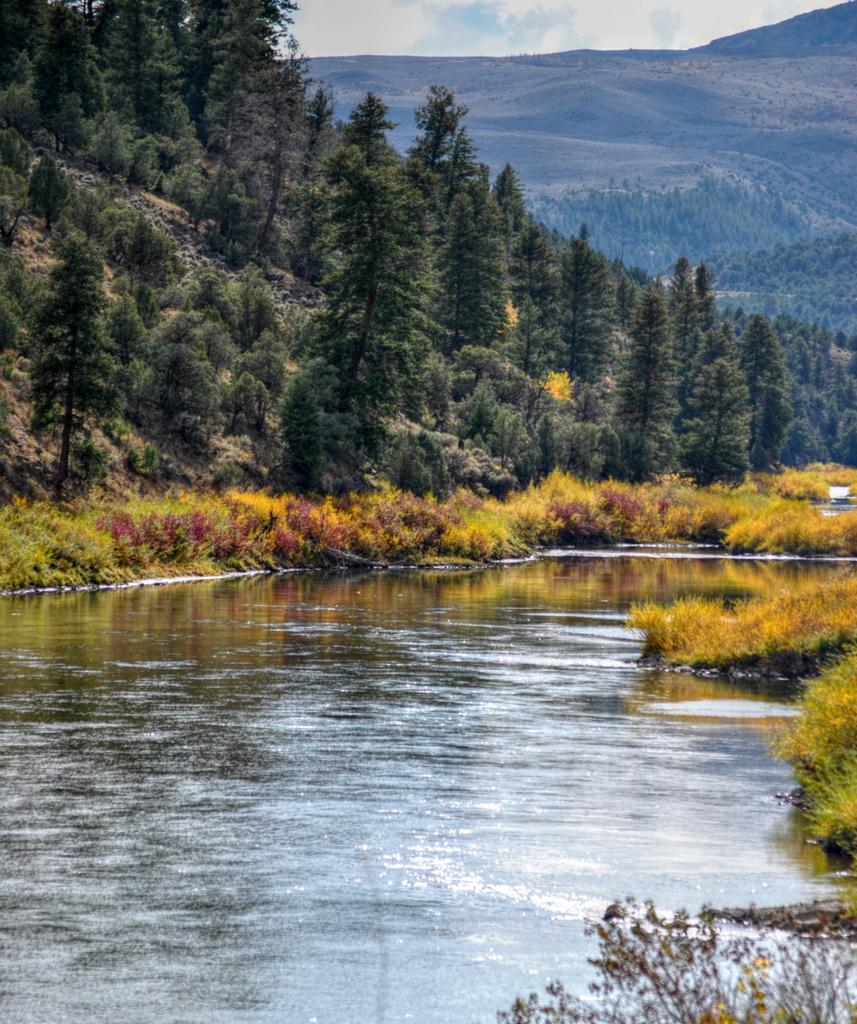What is the primary element visible in the image? There is water in the image. What type of vegetation can be seen in the image? There are trees and grass in the image. What part of the natural environment is visible in the background of the image? The sky is visible in the background of the image. How much water is in the pail in the image? There is no pail present in the image, so it is not possible to determine the amount of water in a pail. 